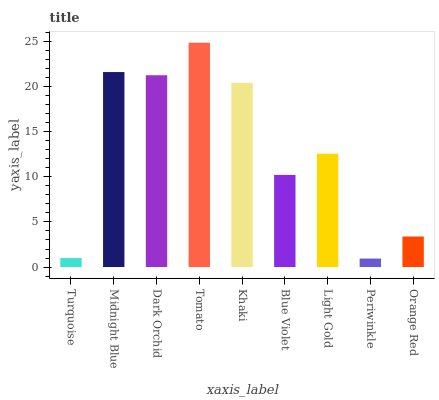Is Periwinkle the minimum?
Answer yes or no. Yes. Is Tomato the maximum?
Answer yes or no. Yes. Is Midnight Blue the minimum?
Answer yes or no. No. Is Midnight Blue the maximum?
Answer yes or no. No. Is Midnight Blue greater than Turquoise?
Answer yes or no. Yes. Is Turquoise less than Midnight Blue?
Answer yes or no. Yes. Is Turquoise greater than Midnight Blue?
Answer yes or no. No. Is Midnight Blue less than Turquoise?
Answer yes or no. No. Is Light Gold the high median?
Answer yes or no. Yes. Is Light Gold the low median?
Answer yes or no. Yes. Is Periwinkle the high median?
Answer yes or no. No. Is Tomato the low median?
Answer yes or no. No. 